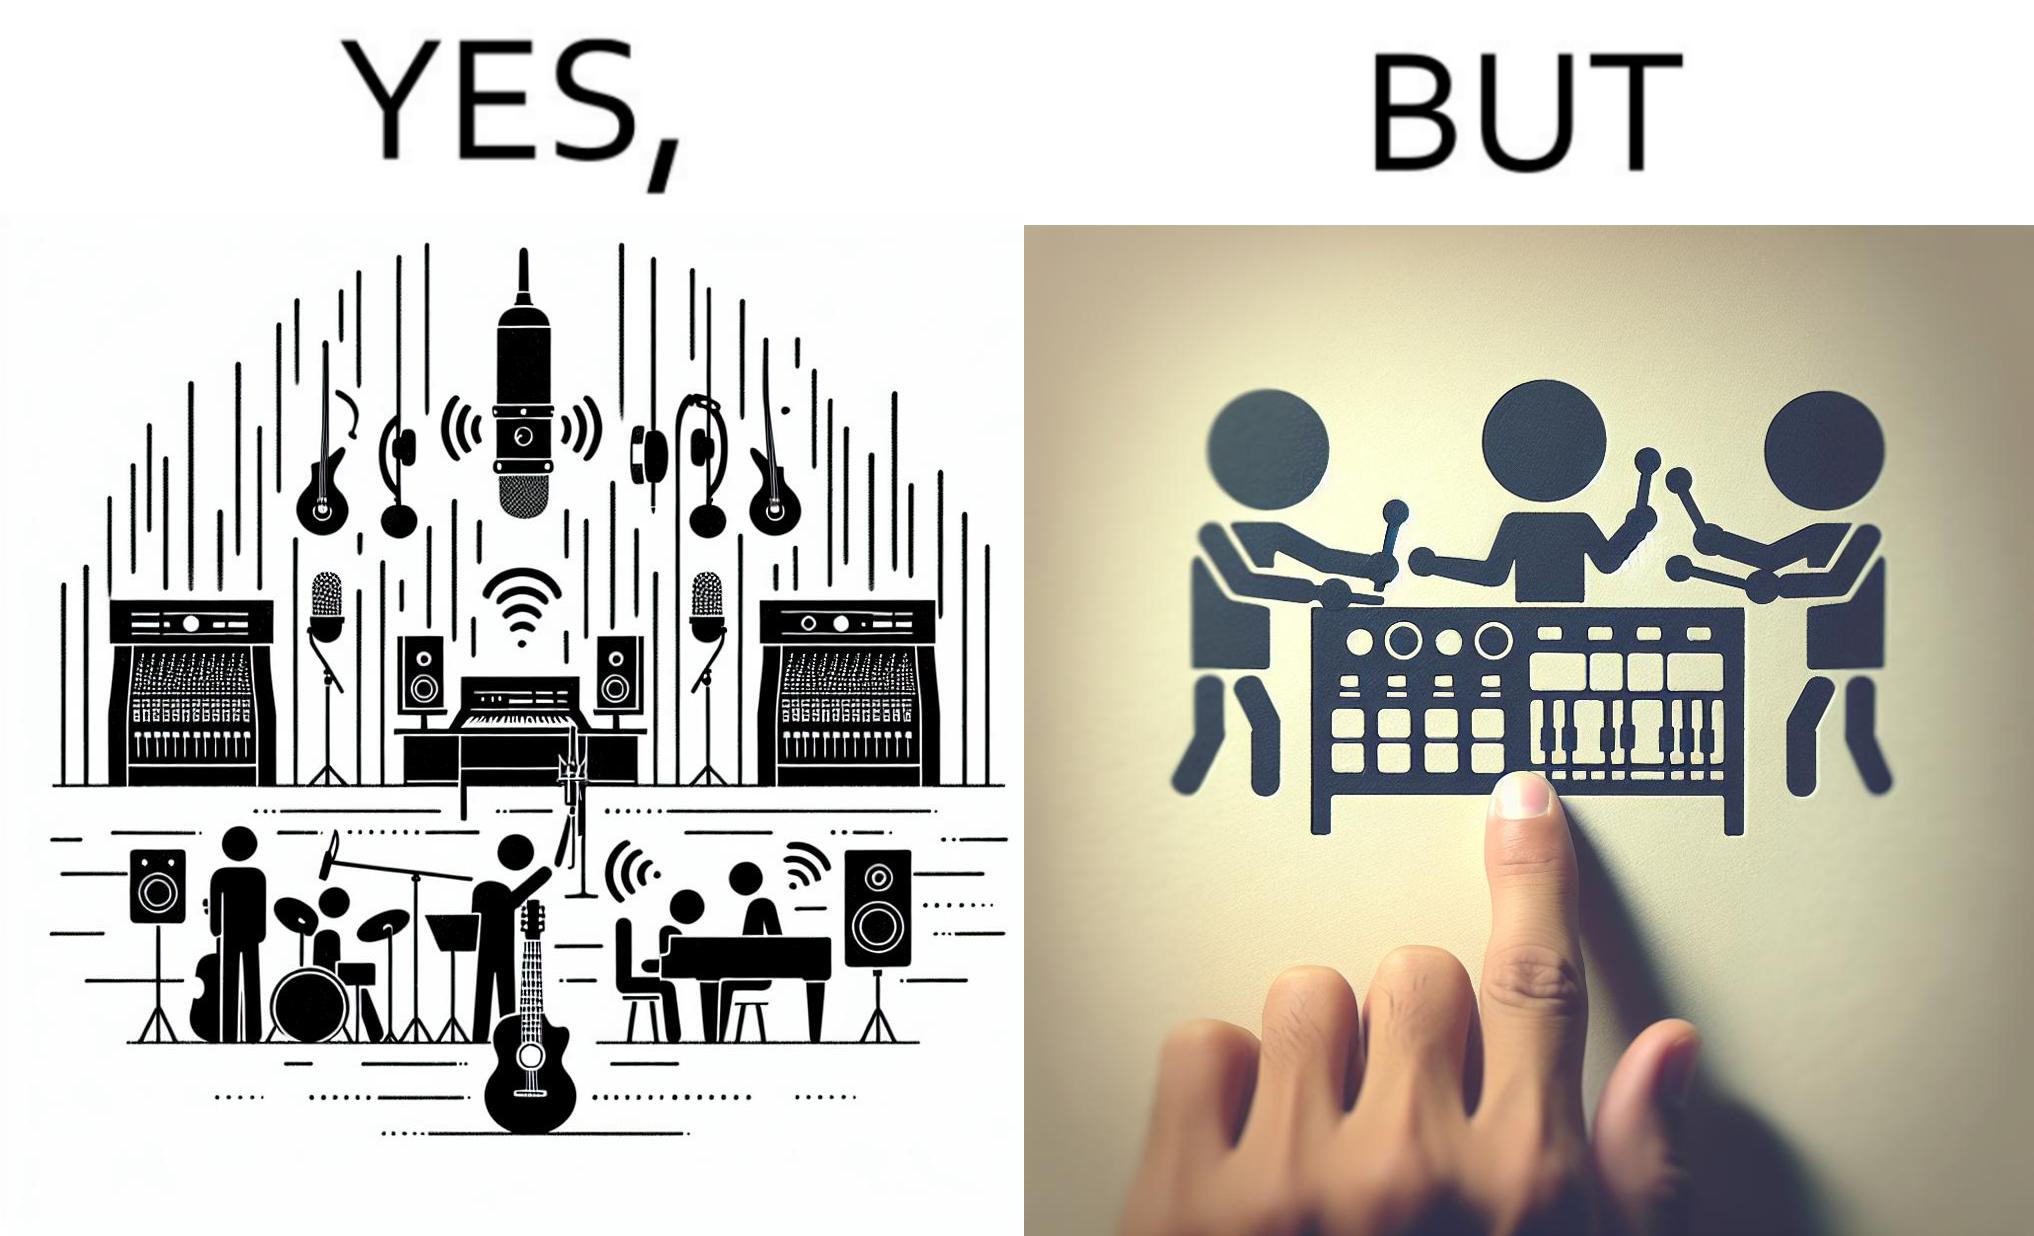Is there satirical content in this image? Yes, this image is satirical. 